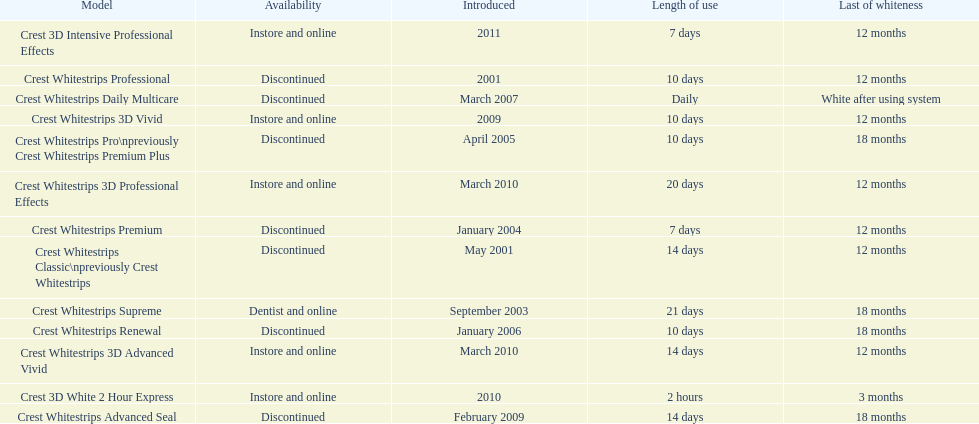I'm looking to parse the entire table for insights. Could you assist me with that? {'header': ['Model', 'Availability', 'Introduced', 'Length of use', 'Last of whiteness'], 'rows': [['Crest 3D Intensive Professional Effects', 'Instore and online', '2011', '7 days', '12 months'], ['Crest Whitestrips Professional', 'Discontinued', '2001', '10 days', '12 months'], ['Crest Whitestrips Daily Multicare', 'Discontinued', 'March 2007', 'Daily', 'White after using system'], ['Crest Whitestrips 3D Vivid', 'Instore and online', '2009', '10 days', '12 months'], ['Crest Whitestrips Pro\\npreviously Crest Whitestrips Premium Plus', 'Discontinued', 'April 2005', '10 days', '18 months'], ['Crest Whitestrips 3D Professional Effects', 'Instore and online', 'March 2010', '20 days', '12 months'], ['Crest Whitestrips Premium', 'Discontinued', 'January 2004', '7 days', '12 months'], ['Crest Whitestrips Classic\\npreviously Crest Whitestrips', 'Discontinued', 'May 2001', '14 days', '12 months'], ['Crest Whitestrips Supreme', 'Dentist and online', 'September 2003', '21 days', '18 months'], ['Crest Whitestrips Renewal', 'Discontinued', 'January 2006', '10 days', '18 months'], ['Crest Whitestrips 3D Advanced Vivid', 'Instore and online', 'March 2010', '14 days', '12 months'], ['Crest 3D White 2 Hour Express', 'Instore and online', '2010', '2 hours', '3 months'], ['Crest Whitestrips Advanced Seal', 'Discontinued', 'February 2009', '14 days', '18 months']]} Which model has the highest 'length of use' to 'last of whiteness' ratio? Crest Whitestrips Supreme. 